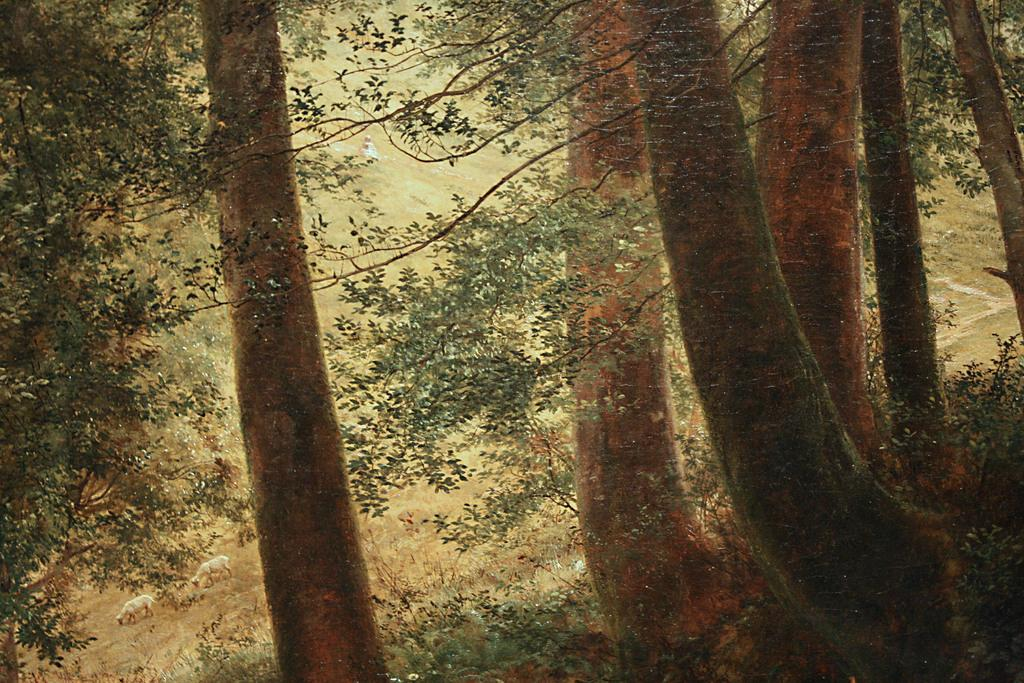What type of vegetation can be seen in the image? There are trees in the image. What are the two animals doing in the image? The two animals are walking on the grass in the image. Can you describe the person in the image? There is a person in the image, but no specific details about their appearance or actions are provided. What type of cart is being pulled by the animals in the image? There is no cart present in the image; the animals are walking on the grass without any visible means of transportation. 